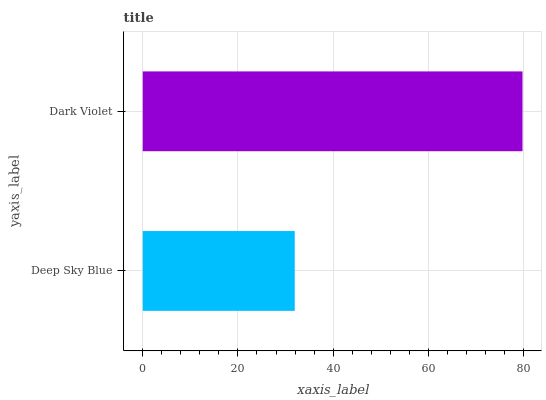Is Deep Sky Blue the minimum?
Answer yes or no. Yes. Is Dark Violet the maximum?
Answer yes or no. Yes. Is Dark Violet the minimum?
Answer yes or no. No. Is Dark Violet greater than Deep Sky Blue?
Answer yes or no. Yes. Is Deep Sky Blue less than Dark Violet?
Answer yes or no. Yes. Is Deep Sky Blue greater than Dark Violet?
Answer yes or no. No. Is Dark Violet less than Deep Sky Blue?
Answer yes or no. No. Is Dark Violet the high median?
Answer yes or no. Yes. Is Deep Sky Blue the low median?
Answer yes or no. Yes. Is Deep Sky Blue the high median?
Answer yes or no. No. Is Dark Violet the low median?
Answer yes or no. No. 